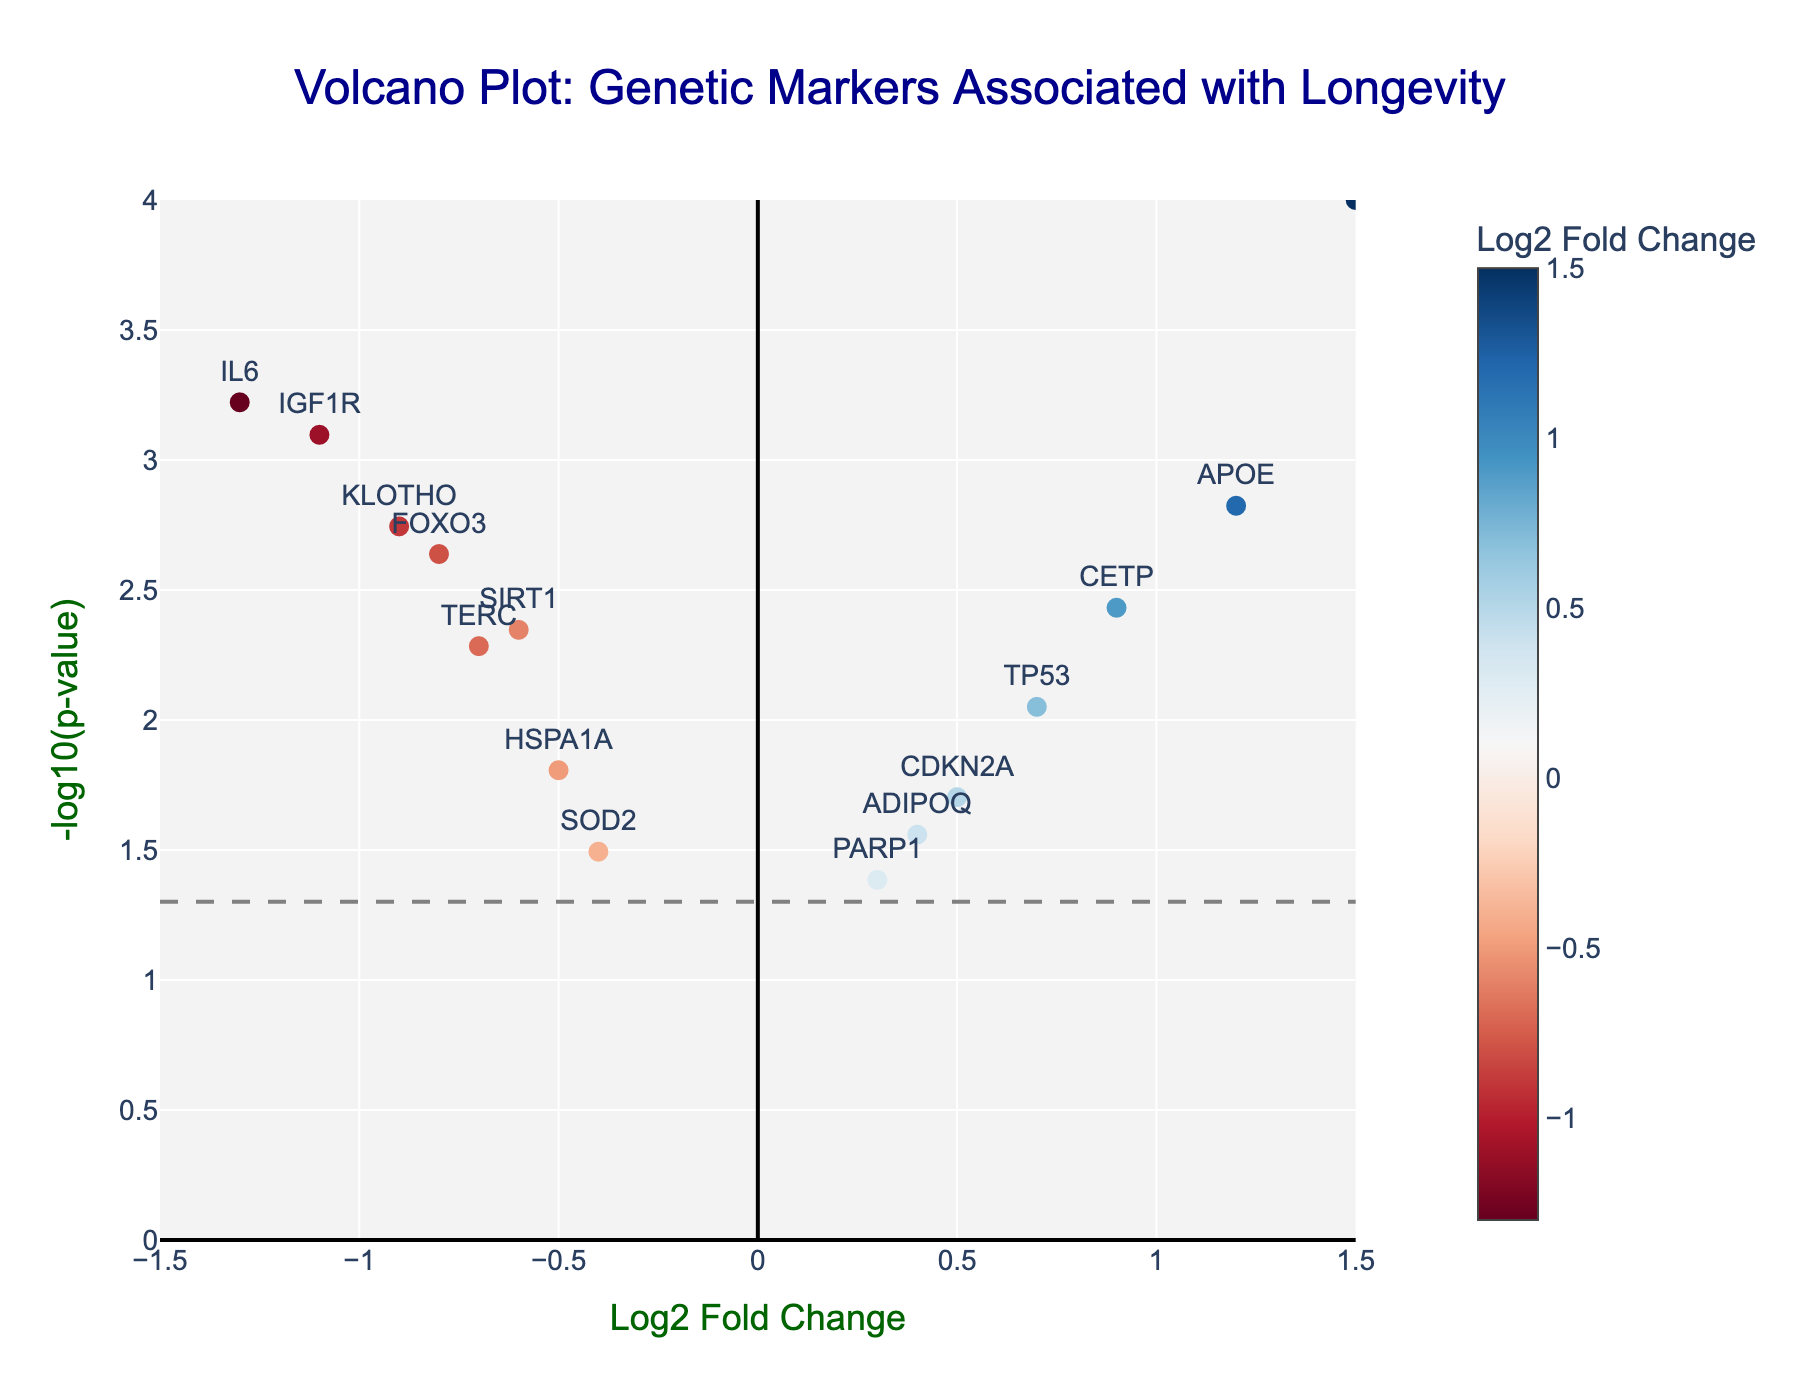What is the title of the figure? The title is displayed at the top center of the figure in dark blue and large font size.
Answer: Volcano Plot: Genetic Markers Associated with Longevity What are the axes labels? The x-axis label is "Log2 Fold Change", and the y-axis label is "-log10(p-value)". Both are in dark green and large font size.
Answer: Log2 Fold Change; -log10(p-value) How many data points are plotted in the figure? By counting the number of markers (points) on the plot, each labeled with a different gene name, you can determine the number of data points. There are 15 data points.
Answer: 15 Which gene has the highest -log10(p-value)? Look for the data point that is highest on the y-axis, which represents -log10(p-value). The gene label closest to the top is LMNA.
Answer: LMNA Which genes have Log2 Fold Change greater than 1? Examine the data points to the right of the vertical line at Log2 Fold Change = 1. Only LMNA has a Log2 Fold Change greater than 1.
Answer: LMNA Which gene is closest to the origin (0,0)? The origin is at the intersection of Log2 Fold Change = 0 and -log10(p-value) = 0. The gene closest to this point is PARP1.
Answer: PARP1 How many genes have a p-value less than 0.05? Any data point above the horizontal line (representing -log10(0.05)) has a p-value less than 0.05. Count these points to get the total number.
Answer: 12 Which gene has the most negative Log2 Fold Change? Look for the data point farthest to the left on the x-axis, indicating the most negative Log2 Fold Change. The gene is IL6.
Answer: IL6 Compare the -log10(p-value) of FOXO3 and APOE. Which gene is more statistically significant? Higher values of -log10(p-value) indicate higher statistical significance. Compare the y-values of FOXO3 and APOE. APOE, with a higher -log10(p-value), is more statistically significant.
Answer: APOE 